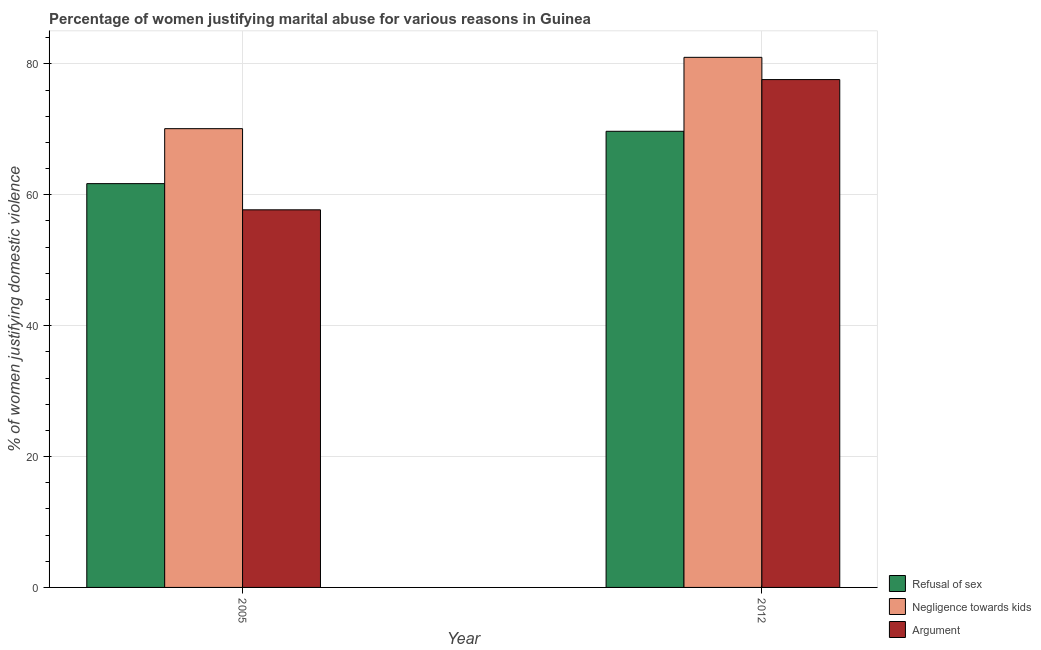How many groups of bars are there?
Make the answer very short. 2. Are the number of bars per tick equal to the number of legend labels?
Keep it short and to the point. Yes. How many bars are there on the 1st tick from the left?
Your answer should be compact. 3. How many bars are there on the 1st tick from the right?
Offer a terse response. 3. What is the percentage of women justifying domestic violence due to refusal of sex in 2005?
Your response must be concise. 61.7. Across all years, what is the maximum percentage of women justifying domestic violence due to refusal of sex?
Offer a terse response. 69.7. Across all years, what is the minimum percentage of women justifying domestic violence due to refusal of sex?
Your answer should be very brief. 61.7. In which year was the percentage of women justifying domestic violence due to refusal of sex minimum?
Keep it short and to the point. 2005. What is the total percentage of women justifying domestic violence due to refusal of sex in the graph?
Provide a succinct answer. 131.4. What is the average percentage of women justifying domestic violence due to refusal of sex per year?
Your answer should be compact. 65.7. In how many years, is the percentage of women justifying domestic violence due to negligence towards kids greater than 80 %?
Your answer should be compact. 1. What is the ratio of the percentage of women justifying domestic violence due to negligence towards kids in 2005 to that in 2012?
Your answer should be very brief. 0.87. Is the percentage of women justifying domestic violence due to arguments in 2005 less than that in 2012?
Ensure brevity in your answer.  Yes. In how many years, is the percentage of women justifying domestic violence due to refusal of sex greater than the average percentage of women justifying domestic violence due to refusal of sex taken over all years?
Your answer should be compact. 1. What does the 3rd bar from the left in 2012 represents?
Provide a succinct answer. Argument. What does the 3rd bar from the right in 2012 represents?
Offer a very short reply. Refusal of sex. Are the values on the major ticks of Y-axis written in scientific E-notation?
Keep it short and to the point. No. Does the graph contain any zero values?
Keep it short and to the point. No. Where does the legend appear in the graph?
Offer a terse response. Bottom right. How are the legend labels stacked?
Your answer should be very brief. Vertical. What is the title of the graph?
Offer a very short reply. Percentage of women justifying marital abuse for various reasons in Guinea. What is the label or title of the Y-axis?
Make the answer very short. % of women justifying domestic violence. What is the % of women justifying domestic violence of Refusal of sex in 2005?
Keep it short and to the point. 61.7. What is the % of women justifying domestic violence in Negligence towards kids in 2005?
Make the answer very short. 70.1. What is the % of women justifying domestic violence in Argument in 2005?
Provide a succinct answer. 57.7. What is the % of women justifying domestic violence of Refusal of sex in 2012?
Give a very brief answer. 69.7. What is the % of women justifying domestic violence of Negligence towards kids in 2012?
Offer a very short reply. 81. What is the % of women justifying domestic violence of Argument in 2012?
Provide a short and direct response. 77.6. Across all years, what is the maximum % of women justifying domestic violence in Refusal of sex?
Provide a succinct answer. 69.7. Across all years, what is the maximum % of women justifying domestic violence in Negligence towards kids?
Provide a succinct answer. 81. Across all years, what is the maximum % of women justifying domestic violence in Argument?
Your answer should be very brief. 77.6. Across all years, what is the minimum % of women justifying domestic violence in Refusal of sex?
Offer a very short reply. 61.7. Across all years, what is the minimum % of women justifying domestic violence in Negligence towards kids?
Offer a terse response. 70.1. Across all years, what is the minimum % of women justifying domestic violence of Argument?
Ensure brevity in your answer.  57.7. What is the total % of women justifying domestic violence of Refusal of sex in the graph?
Make the answer very short. 131.4. What is the total % of women justifying domestic violence in Negligence towards kids in the graph?
Your answer should be compact. 151.1. What is the total % of women justifying domestic violence in Argument in the graph?
Offer a very short reply. 135.3. What is the difference between the % of women justifying domestic violence in Argument in 2005 and that in 2012?
Make the answer very short. -19.9. What is the difference between the % of women justifying domestic violence in Refusal of sex in 2005 and the % of women justifying domestic violence in Negligence towards kids in 2012?
Give a very brief answer. -19.3. What is the difference between the % of women justifying domestic violence of Refusal of sex in 2005 and the % of women justifying domestic violence of Argument in 2012?
Ensure brevity in your answer.  -15.9. What is the average % of women justifying domestic violence in Refusal of sex per year?
Give a very brief answer. 65.7. What is the average % of women justifying domestic violence of Negligence towards kids per year?
Keep it short and to the point. 75.55. What is the average % of women justifying domestic violence of Argument per year?
Give a very brief answer. 67.65. In the year 2005, what is the difference between the % of women justifying domestic violence of Negligence towards kids and % of women justifying domestic violence of Argument?
Make the answer very short. 12.4. In the year 2012, what is the difference between the % of women justifying domestic violence in Refusal of sex and % of women justifying domestic violence in Argument?
Offer a terse response. -7.9. In the year 2012, what is the difference between the % of women justifying domestic violence in Negligence towards kids and % of women justifying domestic violence in Argument?
Give a very brief answer. 3.4. What is the ratio of the % of women justifying domestic violence in Refusal of sex in 2005 to that in 2012?
Your response must be concise. 0.89. What is the ratio of the % of women justifying domestic violence of Negligence towards kids in 2005 to that in 2012?
Offer a very short reply. 0.87. What is the ratio of the % of women justifying domestic violence of Argument in 2005 to that in 2012?
Provide a succinct answer. 0.74. What is the difference between the highest and the second highest % of women justifying domestic violence in Refusal of sex?
Your response must be concise. 8. What is the difference between the highest and the second highest % of women justifying domestic violence in Negligence towards kids?
Make the answer very short. 10.9. What is the difference between the highest and the second highest % of women justifying domestic violence in Argument?
Ensure brevity in your answer.  19.9. What is the difference between the highest and the lowest % of women justifying domestic violence in Argument?
Give a very brief answer. 19.9. 